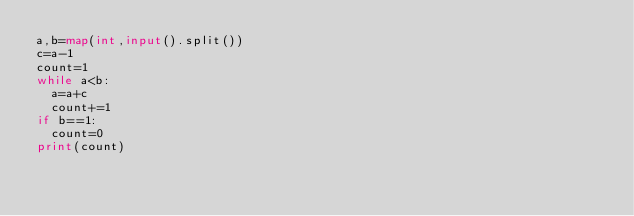<code> <loc_0><loc_0><loc_500><loc_500><_Python_>a,b=map(int,input().split())
c=a-1
count=1
while a<b:
  a=a+c
  count+=1
if b==1:
  count=0
print(count)</code> 